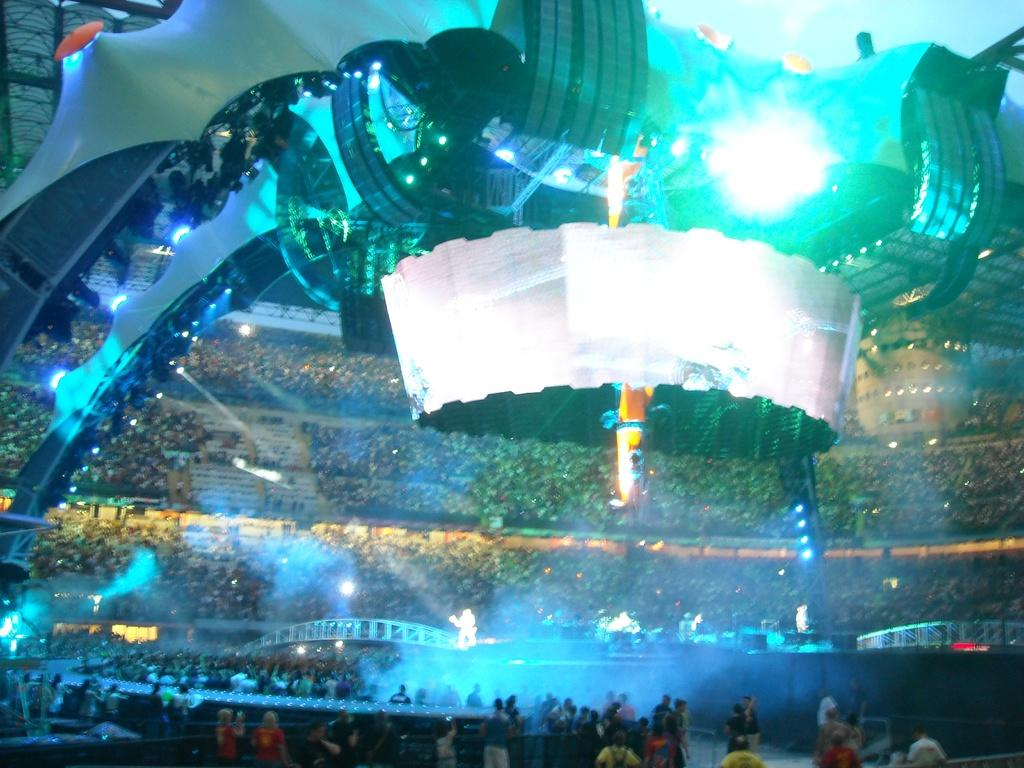What type of venue is shown in the image? The image depicts a stadium. What can be seen inside the stadium? There is a crowd in the stadium. Can you describe the position of some people in the stadium? Some people are standing in the front. What architectural feature is present at the top of the stadium? There is an arch at the top of the stadium. What can be seen illuminating the stadium at night? Lights are visible at the top of the stadium. What safety feature is present in the stadium? Railings are present in the stadium. What type of underwear is being worn by the people in the crowd? There is no information about the underwear being worn by the people in the crowd, as the image does not show such details. 